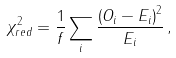Convert formula to latex. <formula><loc_0><loc_0><loc_500><loc_500>\chi ^ { 2 } _ { r e d } = \frac { 1 } { f } \sum _ { i } \frac { \left ( O _ { i } - E _ { i } \right ) ^ { 2 } } { E _ { i } } \, ,</formula> 